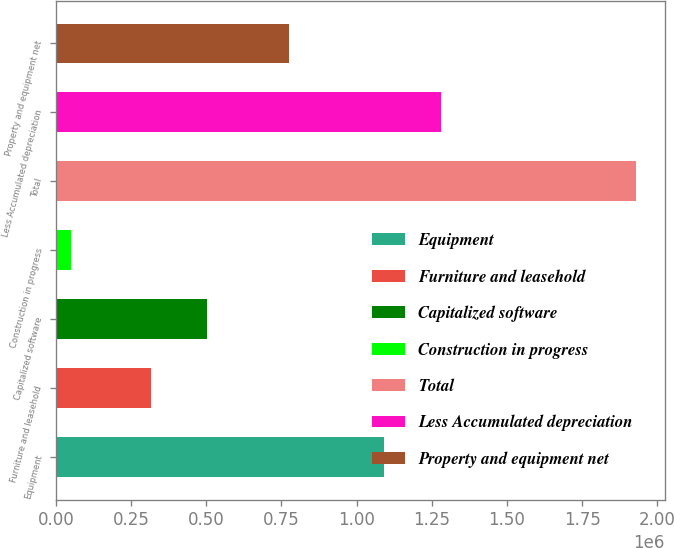Convert chart. <chart><loc_0><loc_0><loc_500><loc_500><bar_chart><fcel>Equipment<fcel>Furniture and leasehold<fcel>Capitalized software<fcel>Construction in progress<fcel>Total<fcel>Less Accumulated depreciation<fcel>Property and equipment net<nl><fcel>1.09167e+06<fcel>314852<fcel>502719<fcel>49417<fcel>1.92809e+06<fcel>1.27954e+06<fcel>773715<nl></chart> 